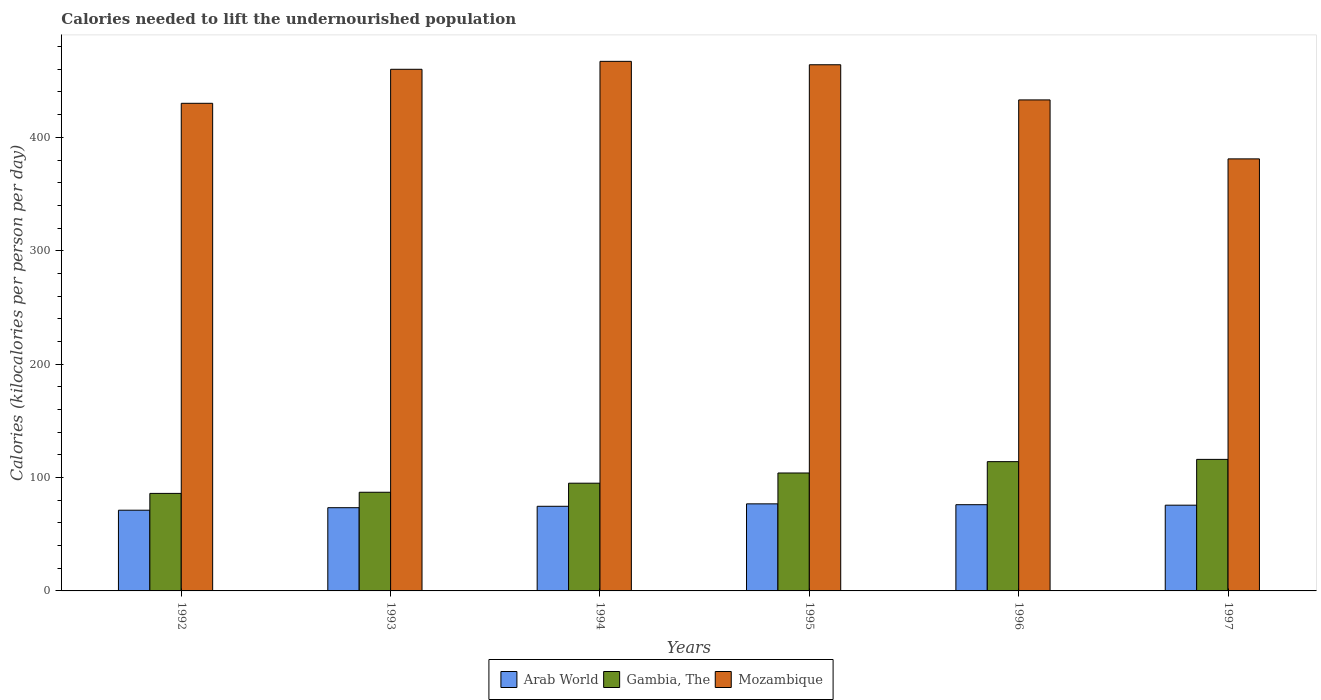How many groups of bars are there?
Your answer should be compact. 6. Are the number of bars on each tick of the X-axis equal?
Give a very brief answer. Yes. How many bars are there on the 5th tick from the right?
Make the answer very short. 3. What is the total calories needed to lift the undernourished population in Arab World in 1997?
Provide a succinct answer. 75.61. Across all years, what is the maximum total calories needed to lift the undernourished population in Arab World?
Provide a short and direct response. 76.78. Across all years, what is the minimum total calories needed to lift the undernourished population in Mozambique?
Ensure brevity in your answer.  381. What is the total total calories needed to lift the undernourished population in Arab World in the graph?
Give a very brief answer. 447.62. What is the difference between the total calories needed to lift the undernourished population in Gambia, The in 1994 and that in 1997?
Your answer should be very brief. -21. What is the difference between the total calories needed to lift the undernourished population in Gambia, The in 1996 and the total calories needed to lift the undernourished population in Mozambique in 1994?
Provide a succinct answer. -353. What is the average total calories needed to lift the undernourished population in Mozambique per year?
Keep it short and to the point. 439.17. In the year 1994, what is the difference between the total calories needed to lift the undernourished population in Arab World and total calories needed to lift the undernourished population in Mozambique?
Ensure brevity in your answer.  -392.37. In how many years, is the total calories needed to lift the undernourished population in Arab World greater than 60 kilocalories?
Offer a terse response. 6. What is the ratio of the total calories needed to lift the undernourished population in Arab World in 1992 to that in 1993?
Provide a succinct answer. 0.97. Is the difference between the total calories needed to lift the undernourished population in Arab World in 1992 and 1995 greater than the difference between the total calories needed to lift the undernourished population in Mozambique in 1992 and 1995?
Your answer should be very brief. Yes. What is the difference between the highest and the second highest total calories needed to lift the undernourished population in Arab World?
Offer a terse response. 0.75. What is the difference between the highest and the lowest total calories needed to lift the undernourished population in Gambia, The?
Ensure brevity in your answer.  30. Is the sum of the total calories needed to lift the undernourished population in Gambia, The in 1994 and 1995 greater than the maximum total calories needed to lift the undernourished population in Arab World across all years?
Ensure brevity in your answer.  Yes. What does the 1st bar from the left in 1997 represents?
Provide a succinct answer. Arab World. What does the 2nd bar from the right in 1994 represents?
Ensure brevity in your answer.  Gambia, The. How many bars are there?
Keep it short and to the point. 18. Are all the bars in the graph horizontal?
Your answer should be compact. No. How are the legend labels stacked?
Ensure brevity in your answer.  Horizontal. What is the title of the graph?
Your answer should be compact. Calories needed to lift the undernourished population. Does "France" appear as one of the legend labels in the graph?
Provide a short and direct response. No. What is the label or title of the Y-axis?
Give a very brief answer. Calories (kilocalories per person per day). What is the Calories (kilocalories per person per day) in Arab World in 1992?
Make the answer very short. 71.17. What is the Calories (kilocalories per person per day) in Mozambique in 1992?
Your response must be concise. 430. What is the Calories (kilocalories per person per day) in Arab World in 1993?
Your answer should be very brief. 73.39. What is the Calories (kilocalories per person per day) in Mozambique in 1993?
Offer a terse response. 460. What is the Calories (kilocalories per person per day) of Arab World in 1994?
Offer a very short reply. 74.63. What is the Calories (kilocalories per person per day) in Mozambique in 1994?
Ensure brevity in your answer.  467. What is the Calories (kilocalories per person per day) of Arab World in 1995?
Your response must be concise. 76.78. What is the Calories (kilocalories per person per day) in Gambia, The in 1995?
Offer a terse response. 104. What is the Calories (kilocalories per person per day) of Mozambique in 1995?
Your answer should be very brief. 464. What is the Calories (kilocalories per person per day) of Arab World in 1996?
Your response must be concise. 76.03. What is the Calories (kilocalories per person per day) in Gambia, The in 1996?
Offer a terse response. 114. What is the Calories (kilocalories per person per day) of Mozambique in 1996?
Provide a short and direct response. 433. What is the Calories (kilocalories per person per day) of Arab World in 1997?
Keep it short and to the point. 75.61. What is the Calories (kilocalories per person per day) in Gambia, The in 1997?
Keep it short and to the point. 116. What is the Calories (kilocalories per person per day) of Mozambique in 1997?
Your answer should be compact. 381. Across all years, what is the maximum Calories (kilocalories per person per day) in Arab World?
Your answer should be very brief. 76.78. Across all years, what is the maximum Calories (kilocalories per person per day) of Gambia, The?
Your answer should be very brief. 116. Across all years, what is the maximum Calories (kilocalories per person per day) in Mozambique?
Ensure brevity in your answer.  467. Across all years, what is the minimum Calories (kilocalories per person per day) in Arab World?
Keep it short and to the point. 71.17. Across all years, what is the minimum Calories (kilocalories per person per day) of Mozambique?
Offer a very short reply. 381. What is the total Calories (kilocalories per person per day) of Arab World in the graph?
Offer a terse response. 447.62. What is the total Calories (kilocalories per person per day) of Gambia, The in the graph?
Give a very brief answer. 602. What is the total Calories (kilocalories per person per day) in Mozambique in the graph?
Provide a succinct answer. 2635. What is the difference between the Calories (kilocalories per person per day) in Arab World in 1992 and that in 1993?
Offer a terse response. -2.22. What is the difference between the Calories (kilocalories per person per day) in Arab World in 1992 and that in 1994?
Your answer should be compact. -3.46. What is the difference between the Calories (kilocalories per person per day) of Gambia, The in 1992 and that in 1994?
Keep it short and to the point. -9. What is the difference between the Calories (kilocalories per person per day) in Mozambique in 1992 and that in 1994?
Keep it short and to the point. -37. What is the difference between the Calories (kilocalories per person per day) of Arab World in 1992 and that in 1995?
Provide a short and direct response. -5.61. What is the difference between the Calories (kilocalories per person per day) of Gambia, The in 1992 and that in 1995?
Your answer should be very brief. -18. What is the difference between the Calories (kilocalories per person per day) in Mozambique in 1992 and that in 1995?
Your answer should be very brief. -34. What is the difference between the Calories (kilocalories per person per day) of Arab World in 1992 and that in 1996?
Keep it short and to the point. -4.86. What is the difference between the Calories (kilocalories per person per day) of Mozambique in 1992 and that in 1996?
Give a very brief answer. -3. What is the difference between the Calories (kilocalories per person per day) of Arab World in 1992 and that in 1997?
Keep it short and to the point. -4.44. What is the difference between the Calories (kilocalories per person per day) of Gambia, The in 1992 and that in 1997?
Provide a short and direct response. -30. What is the difference between the Calories (kilocalories per person per day) in Arab World in 1993 and that in 1994?
Keep it short and to the point. -1.24. What is the difference between the Calories (kilocalories per person per day) in Mozambique in 1993 and that in 1994?
Make the answer very short. -7. What is the difference between the Calories (kilocalories per person per day) in Arab World in 1993 and that in 1995?
Ensure brevity in your answer.  -3.39. What is the difference between the Calories (kilocalories per person per day) of Gambia, The in 1993 and that in 1995?
Provide a succinct answer. -17. What is the difference between the Calories (kilocalories per person per day) in Arab World in 1993 and that in 1996?
Give a very brief answer. -2.64. What is the difference between the Calories (kilocalories per person per day) in Arab World in 1993 and that in 1997?
Keep it short and to the point. -2.22. What is the difference between the Calories (kilocalories per person per day) of Mozambique in 1993 and that in 1997?
Ensure brevity in your answer.  79. What is the difference between the Calories (kilocalories per person per day) of Arab World in 1994 and that in 1995?
Keep it short and to the point. -2.15. What is the difference between the Calories (kilocalories per person per day) of Mozambique in 1994 and that in 1995?
Provide a short and direct response. 3. What is the difference between the Calories (kilocalories per person per day) of Arab World in 1994 and that in 1996?
Provide a short and direct response. -1.4. What is the difference between the Calories (kilocalories per person per day) in Gambia, The in 1994 and that in 1996?
Keep it short and to the point. -19. What is the difference between the Calories (kilocalories per person per day) of Arab World in 1994 and that in 1997?
Offer a very short reply. -0.98. What is the difference between the Calories (kilocalories per person per day) of Arab World in 1995 and that in 1996?
Offer a very short reply. 0.75. What is the difference between the Calories (kilocalories per person per day) of Mozambique in 1995 and that in 1996?
Keep it short and to the point. 31. What is the difference between the Calories (kilocalories per person per day) of Arab World in 1995 and that in 1997?
Your response must be concise. 1.17. What is the difference between the Calories (kilocalories per person per day) in Gambia, The in 1995 and that in 1997?
Keep it short and to the point. -12. What is the difference between the Calories (kilocalories per person per day) in Arab World in 1996 and that in 1997?
Offer a terse response. 0.42. What is the difference between the Calories (kilocalories per person per day) in Gambia, The in 1996 and that in 1997?
Offer a terse response. -2. What is the difference between the Calories (kilocalories per person per day) of Mozambique in 1996 and that in 1997?
Your answer should be very brief. 52. What is the difference between the Calories (kilocalories per person per day) in Arab World in 1992 and the Calories (kilocalories per person per day) in Gambia, The in 1993?
Offer a terse response. -15.83. What is the difference between the Calories (kilocalories per person per day) of Arab World in 1992 and the Calories (kilocalories per person per day) of Mozambique in 1993?
Offer a terse response. -388.83. What is the difference between the Calories (kilocalories per person per day) in Gambia, The in 1992 and the Calories (kilocalories per person per day) in Mozambique in 1993?
Your answer should be compact. -374. What is the difference between the Calories (kilocalories per person per day) of Arab World in 1992 and the Calories (kilocalories per person per day) of Gambia, The in 1994?
Provide a succinct answer. -23.83. What is the difference between the Calories (kilocalories per person per day) in Arab World in 1992 and the Calories (kilocalories per person per day) in Mozambique in 1994?
Offer a very short reply. -395.83. What is the difference between the Calories (kilocalories per person per day) of Gambia, The in 1992 and the Calories (kilocalories per person per day) of Mozambique in 1994?
Your answer should be very brief. -381. What is the difference between the Calories (kilocalories per person per day) of Arab World in 1992 and the Calories (kilocalories per person per day) of Gambia, The in 1995?
Your answer should be very brief. -32.83. What is the difference between the Calories (kilocalories per person per day) of Arab World in 1992 and the Calories (kilocalories per person per day) of Mozambique in 1995?
Provide a succinct answer. -392.83. What is the difference between the Calories (kilocalories per person per day) of Gambia, The in 1992 and the Calories (kilocalories per person per day) of Mozambique in 1995?
Ensure brevity in your answer.  -378. What is the difference between the Calories (kilocalories per person per day) of Arab World in 1992 and the Calories (kilocalories per person per day) of Gambia, The in 1996?
Offer a very short reply. -42.83. What is the difference between the Calories (kilocalories per person per day) in Arab World in 1992 and the Calories (kilocalories per person per day) in Mozambique in 1996?
Make the answer very short. -361.83. What is the difference between the Calories (kilocalories per person per day) of Gambia, The in 1992 and the Calories (kilocalories per person per day) of Mozambique in 1996?
Offer a terse response. -347. What is the difference between the Calories (kilocalories per person per day) of Arab World in 1992 and the Calories (kilocalories per person per day) of Gambia, The in 1997?
Your answer should be very brief. -44.83. What is the difference between the Calories (kilocalories per person per day) in Arab World in 1992 and the Calories (kilocalories per person per day) in Mozambique in 1997?
Make the answer very short. -309.83. What is the difference between the Calories (kilocalories per person per day) in Gambia, The in 1992 and the Calories (kilocalories per person per day) in Mozambique in 1997?
Your answer should be very brief. -295. What is the difference between the Calories (kilocalories per person per day) of Arab World in 1993 and the Calories (kilocalories per person per day) of Gambia, The in 1994?
Give a very brief answer. -21.61. What is the difference between the Calories (kilocalories per person per day) of Arab World in 1993 and the Calories (kilocalories per person per day) of Mozambique in 1994?
Provide a short and direct response. -393.61. What is the difference between the Calories (kilocalories per person per day) in Gambia, The in 1993 and the Calories (kilocalories per person per day) in Mozambique in 1994?
Provide a short and direct response. -380. What is the difference between the Calories (kilocalories per person per day) of Arab World in 1993 and the Calories (kilocalories per person per day) of Gambia, The in 1995?
Your answer should be compact. -30.61. What is the difference between the Calories (kilocalories per person per day) in Arab World in 1993 and the Calories (kilocalories per person per day) in Mozambique in 1995?
Give a very brief answer. -390.61. What is the difference between the Calories (kilocalories per person per day) in Gambia, The in 1993 and the Calories (kilocalories per person per day) in Mozambique in 1995?
Offer a very short reply. -377. What is the difference between the Calories (kilocalories per person per day) of Arab World in 1993 and the Calories (kilocalories per person per day) of Gambia, The in 1996?
Your answer should be very brief. -40.61. What is the difference between the Calories (kilocalories per person per day) of Arab World in 1993 and the Calories (kilocalories per person per day) of Mozambique in 1996?
Offer a very short reply. -359.61. What is the difference between the Calories (kilocalories per person per day) of Gambia, The in 1993 and the Calories (kilocalories per person per day) of Mozambique in 1996?
Provide a succinct answer. -346. What is the difference between the Calories (kilocalories per person per day) in Arab World in 1993 and the Calories (kilocalories per person per day) in Gambia, The in 1997?
Your answer should be very brief. -42.61. What is the difference between the Calories (kilocalories per person per day) in Arab World in 1993 and the Calories (kilocalories per person per day) in Mozambique in 1997?
Ensure brevity in your answer.  -307.61. What is the difference between the Calories (kilocalories per person per day) in Gambia, The in 1993 and the Calories (kilocalories per person per day) in Mozambique in 1997?
Offer a terse response. -294. What is the difference between the Calories (kilocalories per person per day) in Arab World in 1994 and the Calories (kilocalories per person per day) in Gambia, The in 1995?
Make the answer very short. -29.37. What is the difference between the Calories (kilocalories per person per day) in Arab World in 1994 and the Calories (kilocalories per person per day) in Mozambique in 1995?
Keep it short and to the point. -389.37. What is the difference between the Calories (kilocalories per person per day) of Gambia, The in 1994 and the Calories (kilocalories per person per day) of Mozambique in 1995?
Your answer should be very brief. -369. What is the difference between the Calories (kilocalories per person per day) in Arab World in 1994 and the Calories (kilocalories per person per day) in Gambia, The in 1996?
Offer a terse response. -39.37. What is the difference between the Calories (kilocalories per person per day) in Arab World in 1994 and the Calories (kilocalories per person per day) in Mozambique in 1996?
Make the answer very short. -358.37. What is the difference between the Calories (kilocalories per person per day) in Gambia, The in 1994 and the Calories (kilocalories per person per day) in Mozambique in 1996?
Give a very brief answer. -338. What is the difference between the Calories (kilocalories per person per day) in Arab World in 1994 and the Calories (kilocalories per person per day) in Gambia, The in 1997?
Your answer should be very brief. -41.37. What is the difference between the Calories (kilocalories per person per day) in Arab World in 1994 and the Calories (kilocalories per person per day) in Mozambique in 1997?
Your answer should be compact. -306.37. What is the difference between the Calories (kilocalories per person per day) of Gambia, The in 1994 and the Calories (kilocalories per person per day) of Mozambique in 1997?
Offer a very short reply. -286. What is the difference between the Calories (kilocalories per person per day) in Arab World in 1995 and the Calories (kilocalories per person per day) in Gambia, The in 1996?
Your answer should be compact. -37.22. What is the difference between the Calories (kilocalories per person per day) of Arab World in 1995 and the Calories (kilocalories per person per day) of Mozambique in 1996?
Provide a short and direct response. -356.22. What is the difference between the Calories (kilocalories per person per day) of Gambia, The in 1995 and the Calories (kilocalories per person per day) of Mozambique in 1996?
Offer a terse response. -329. What is the difference between the Calories (kilocalories per person per day) of Arab World in 1995 and the Calories (kilocalories per person per day) of Gambia, The in 1997?
Keep it short and to the point. -39.22. What is the difference between the Calories (kilocalories per person per day) of Arab World in 1995 and the Calories (kilocalories per person per day) of Mozambique in 1997?
Your answer should be very brief. -304.22. What is the difference between the Calories (kilocalories per person per day) of Gambia, The in 1995 and the Calories (kilocalories per person per day) of Mozambique in 1997?
Offer a very short reply. -277. What is the difference between the Calories (kilocalories per person per day) in Arab World in 1996 and the Calories (kilocalories per person per day) in Gambia, The in 1997?
Ensure brevity in your answer.  -39.97. What is the difference between the Calories (kilocalories per person per day) in Arab World in 1996 and the Calories (kilocalories per person per day) in Mozambique in 1997?
Provide a short and direct response. -304.97. What is the difference between the Calories (kilocalories per person per day) in Gambia, The in 1996 and the Calories (kilocalories per person per day) in Mozambique in 1997?
Offer a very short reply. -267. What is the average Calories (kilocalories per person per day) in Arab World per year?
Ensure brevity in your answer.  74.6. What is the average Calories (kilocalories per person per day) in Gambia, The per year?
Ensure brevity in your answer.  100.33. What is the average Calories (kilocalories per person per day) of Mozambique per year?
Your answer should be very brief. 439.17. In the year 1992, what is the difference between the Calories (kilocalories per person per day) of Arab World and Calories (kilocalories per person per day) of Gambia, The?
Provide a short and direct response. -14.83. In the year 1992, what is the difference between the Calories (kilocalories per person per day) in Arab World and Calories (kilocalories per person per day) in Mozambique?
Your answer should be very brief. -358.83. In the year 1992, what is the difference between the Calories (kilocalories per person per day) of Gambia, The and Calories (kilocalories per person per day) of Mozambique?
Your answer should be compact. -344. In the year 1993, what is the difference between the Calories (kilocalories per person per day) in Arab World and Calories (kilocalories per person per day) in Gambia, The?
Your answer should be very brief. -13.61. In the year 1993, what is the difference between the Calories (kilocalories per person per day) in Arab World and Calories (kilocalories per person per day) in Mozambique?
Keep it short and to the point. -386.61. In the year 1993, what is the difference between the Calories (kilocalories per person per day) of Gambia, The and Calories (kilocalories per person per day) of Mozambique?
Ensure brevity in your answer.  -373. In the year 1994, what is the difference between the Calories (kilocalories per person per day) of Arab World and Calories (kilocalories per person per day) of Gambia, The?
Provide a succinct answer. -20.37. In the year 1994, what is the difference between the Calories (kilocalories per person per day) of Arab World and Calories (kilocalories per person per day) of Mozambique?
Ensure brevity in your answer.  -392.37. In the year 1994, what is the difference between the Calories (kilocalories per person per day) in Gambia, The and Calories (kilocalories per person per day) in Mozambique?
Your answer should be compact. -372. In the year 1995, what is the difference between the Calories (kilocalories per person per day) in Arab World and Calories (kilocalories per person per day) in Gambia, The?
Keep it short and to the point. -27.22. In the year 1995, what is the difference between the Calories (kilocalories per person per day) of Arab World and Calories (kilocalories per person per day) of Mozambique?
Provide a succinct answer. -387.22. In the year 1995, what is the difference between the Calories (kilocalories per person per day) in Gambia, The and Calories (kilocalories per person per day) in Mozambique?
Give a very brief answer. -360. In the year 1996, what is the difference between the Calories (kilocalories per person per day) in Arab World and Calories (kilocalories per person per day) in Gambia, The?
Give a very brief answer. -37.97. In the year 1996, what is the difference between the Calories (kilocalories per person per day) of Arab World and Calories (kilocalories per person per day) of Mozambique?
Offer a terse response. -356.97. In the year 1996, what is the difference between the Calories (kilocalories per person per day) in Gambia, The and Calories (kilocalories per person per day) in Mozambique?
Ensure brevity in your answer.  -319. In the year 1997, what is the difference between the Calories (kilocalories per person per day) in Arab World and Calories (kilocalories per person per day) in Gambia, The?
Your answer should be very brief. -40.39. In the year 1997, what is the difference between the Calories (kilocalories per person per day) of Arab World and Calories (kilocalories per person per day) of Mozambique?
Provide a succinct answer. -305.39. In the year 1997, what is the difference between the Calories (kilocalories per person per day) of Gambia, The and Calories (kilocalories per person per day) of Mozambique?
Keep it short and to the point. -265. What is the ratio of the Calories (kilocalories per person per day) of Arab World in 1992 to that in 1993?
Keep it short and to the point. 0.97. What is the ratio of the Calories (kilocalories per person per day) of Gambia, The in 1992 to that in 1993?
Ensure brevity in your answer.  0.99. What is the ratio of the Calories (kilocalories per person per day) of Mozambique in 1992 to that in 1993?
Offer a very short reply. 0.93. What is the ratio of the Calories (kilocalories per person per day) in Arab World in 1992 to that in 1994?
Provide a short and direct response. 0.95. What is the ratio of the Calories (kilocalories per person per day) in Gambia, The in 1992 to that in 1994?
Ensure brevity in your answer.  0.91. What is the ratio of the Calories (kilocalories per person per day) in Mozambique in 1992 to that in 1994?
Your answer should be compact. 0.92. What is the ratio of the Calories (kilocalories per person per day) in Arab World in 1992 to that in 1995?
Ensure brevity in your answer.  0.93. What is the ratio of the Calories (kilocalories per person per day) of Gambia, The in 1992 to that in 1995?
Your response must be concise. 0.83. What is the ratio of the Calories (kilocalories per person per day) in Mozambique in 1992 to that in 1995?
Ensure brevity in your answer.  0.93. What is the ratio of the Calories (kilocalories per person per day) of Arab World in 1992 to that in 1996?
Make the answer very short. 0.94. What is the ratio of the Calories (kilocalories per person per day) in Gambia, The in 1992 to that in 1996?
Offer a terse response. 0.75. What is the ratio of the Calories (kilocalories per person per day) in Mozambique in 1992 to that in 1996?
Offer a very short reply. 0.99. What is the ratio of the Calories (kilocalories per person per day) of Arab World in 1992 to that in 1997?
Give a very brief answer. 0.94. What is the ratio of the Calories (kilocalories per person per day) in Gambia, The in 1992 to that in 1997?
Offer a terse response. 0.74. What is the ratio of the Calories (kilocalories per person per day) in Mozambique in 1992 to that in 1997?
Your answer should be compact. 1.13. What is the ratio of the Calories (kilocalories per person per day) in Arab World in 1993 to that in 1994?
Your answer should be compact. 0.98. What is the ratio of the Calories (kilocalories per person per day) of Gambia, The in 1993 to that in 1994?
Provide a succinct answer. 0.92. What is the ratio of the Calories (kilocalories per person per day) of Mozambique in 1993 to that in 1994?
Your answer should be very brief. 0.98. What is the ratio of the Calories (kilocalories per person per day) of Arab World in 1993 to that in 1995?
Your answer should be compact. 0.96. What is the ratio of the Calories (kilocalories per person per day) in Gambia, The in 1993 to that in 1995?
Make the answer very short. 0.84. What is the ratio of the Calories (kilocalories per person per day) in Arab World in 1993 to that in 1996?
Give a very brief answer. 0.97. What is the ratio of the Calories (kilocalories per person per day) in Gambia, The in 1993 to that in 1996?
Ensure brevity in your answer.  0.76. What is the ratio of the Calories (kilocalories per person per day) of Mozambique in 1993 to that in 1996?
Your answer should be compact. 1.06. What is the ratio of the Calories (kilocalories per person per day) in Arab World in 1993 to that in 1997?
Offer a terse response. 0.97. What is the ratio of the Calories (kilocalories per person per day) of Mozambique in 1993 to that in 1997?
Your answer should be compact. 1.21. What is the ratio of the Calories (kilocalories per person per day) in Arab World in 1994 to that in 1995?
Offer a terse response. 0.97. What is the ratio of the Calories (kilocalories per person per day) in Gambia, The in 1994 to that in 1995?
Make the answer very short. 0.91. What is the ratio of the Calories (kilocalories per person per day) of Mozambique in 1994 to that in 1995?
Your answer should be very brief. 1.01. What is the ratio of the Calories (kilocalories per person per day) in Arab World in 1994 to that in 1996?
Your answer should be very brief. 0.98. What is the ratio of the Calories (kilocalories per person per day) of Gambia, The in 1994 to that in 1996?
Give a very brief answer. 0.83. What is the ratio of the Calories (kilocalories per person per day) of Mozambique in 1994 to that in 1996?
Your response must be concise. 1.08. What is the ratio of the Calories (kilocalories per person per day) in Arab World in 1994 to that in 1997?
Your answer should be very brief. 0.99. What is the ratio of the Calories (kilocalories per person per day) of Gambia, The in 1994 to that in 1997?
Give a very brief answer. 0.82. What is the ratio of the Calories (kilocalories per person per day) in Mozambique in 1994 to that in 1997?
Make the answer very short. 1.23. What is the ratio of the Calories (kilocalories per person per day) of Arab World in 1995 to that in 1996?
Your answer should be very brief. 1.01. What is the ratio of the Calories (kilocalories per person per day) of Gambia, The in 1995 to that in 1996?
Offer a very short reply. 0.91. What is the ratio of the Calories (kilocalories per person per day) in Mozambique in 1995 to that in 1996?
Your response must be concise. 1.07. What is the ratio of the Calories (kilocalories per person per day) of Arab World in 1995 to that in 1997?
Your answer should be very brief. 1.02. What is the ratio of the Calories (kilocalories per person per day) in Gambia, The in 1995 to that in 1997?
Make the answer very short. 0.9. What is the ratio of the Calories (kilocalories per person per day) in Mozambique in 1995 to that in 1997?
Offer a terse response. 1.22. What is the ratio of the Calories (kilocalories per person per day) of Arab World in 1996 to that in 1997?
Offer a very short reply. 1.01. What is the ratio of the Calories (kilocalories per person per day) of Gambia, The in 1996 to that in 1997?
Offer a terse response. 0.98. What is the ratio of the Calories (kilocalories per person per day) of Mozambique in 1996 to that in 1997?
Your answer should be compact. 1.14. What is the difference between the highest and the second highest Calories (kilocalories per person per day) in Arab World?
Your answer should be compact. 0.75. What is the difference between the highest and the second highest Calories (kilocalories per person per day) in Mozambique?
Your response must be concise. 3. What is the difference between the highest and the lowest Calories (kilocalories per person per day) in Arab World?
Ensure brevity in your answer.  5.61. What is the difference between the highest and the lowest Calories (kilocalories per person per day) in Gambia, The?
Ensure brevity in your answer.  30. 